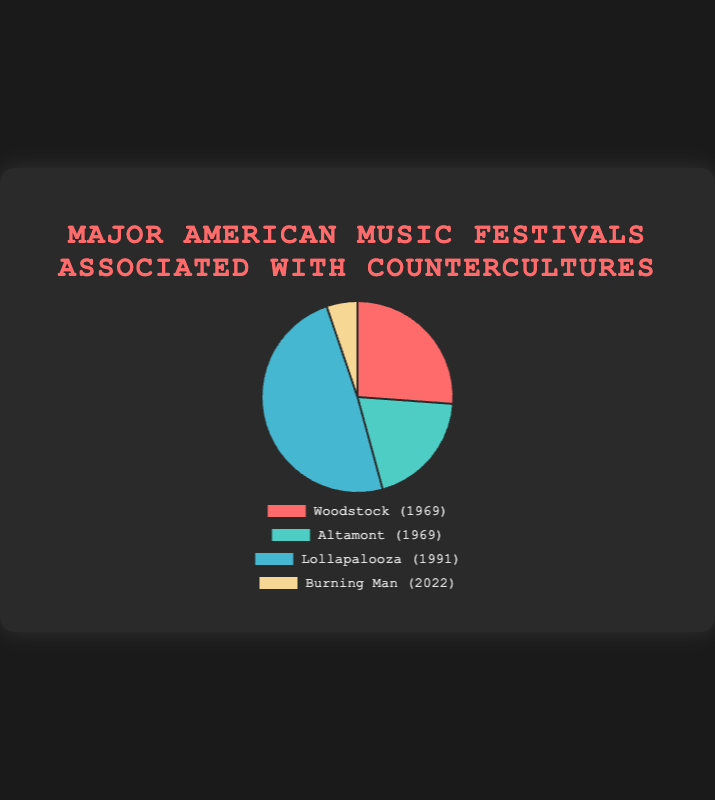Which festival had the highest estimated attendance? From the pie chart, the largest slice corresponds to the festival with the highest attendance. The color indicating Lollapalooza has the largest slice, representing the highest attendance.
Answer: Lollapalooza What is the combined estimated attendance for Woodstock and Altamont? Add the estimated attendance figures for Woodstock (400,000) and Altamont (300,000). The sum is 400,000 + 300,000.
Answer: 700000 Which festival had the lowest estimated attendance? The smallest slice in the pie chart represents the festival with the lowest attendance. The color indicating Burning Man has the smallest slice.
Answer: Burning Man How much larger is the attendance of Lollapalooza compared to Burning Man? Subtract the attendance of Burning Man (80,000) from Lollapalooza (750,000). The result is 750,000 - 80,000.
Answer: 670000 Which two festivals combined have an estimated attendance closest to Lollapalooza's? Combine the attendance figures of festivals that sum up closest to Lollapalooza’s 750,000. The sum of Woodstock (400,000) and Altamont (300,000) is 700,000, which is closest to 750,000 compared to other combinations.
Answer: Woodstock and Altamont What percentage of the total attendance do the estimated attendees of Burning Man represent? First, calculate the total attendance by summing all festivals’ attendance (400,000 + 300,000 + 750,000 + 80,000 = 1,530,000). Then, find the percentage of Burning Man by dividing its attendance by the total and multiplying by 100 (80,000 / 1,530,000 * 100).
Answer: 5.23% What is the median attendance among all the festivals? List the attendance figures in order: 80,000, 300,000, 400,000, 750,000. The median is the average of the two middle numbers (300,000 and 400,000). (300,000 + 400,000) / 2.
Answer: 350000 How does the attendance of Altamont compare to that of Woodstock? Identify the slices corresponding to Altamont (300,000) and Woodstock (400,000). Altamont's attendance is less than Woodstock's.
Answer: Less than Which festival's slice is represented by a green color? Visually locate the slice colored in green from the pie chart, which corresponds to Altamont as per the chart’s legend.
Answer: Altamont 